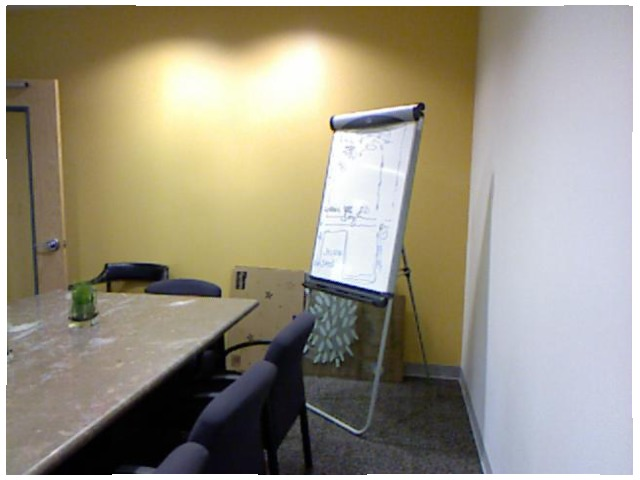<image>
Is there a board shadow on the wall? Yes. Looking at the image, I can see the board shadow is positioned on top of the wall, with the wall providing support. Is there a paper above the easel? No. The paper is not positioned above the easel. The vertical arrangement shows a different relationship. 